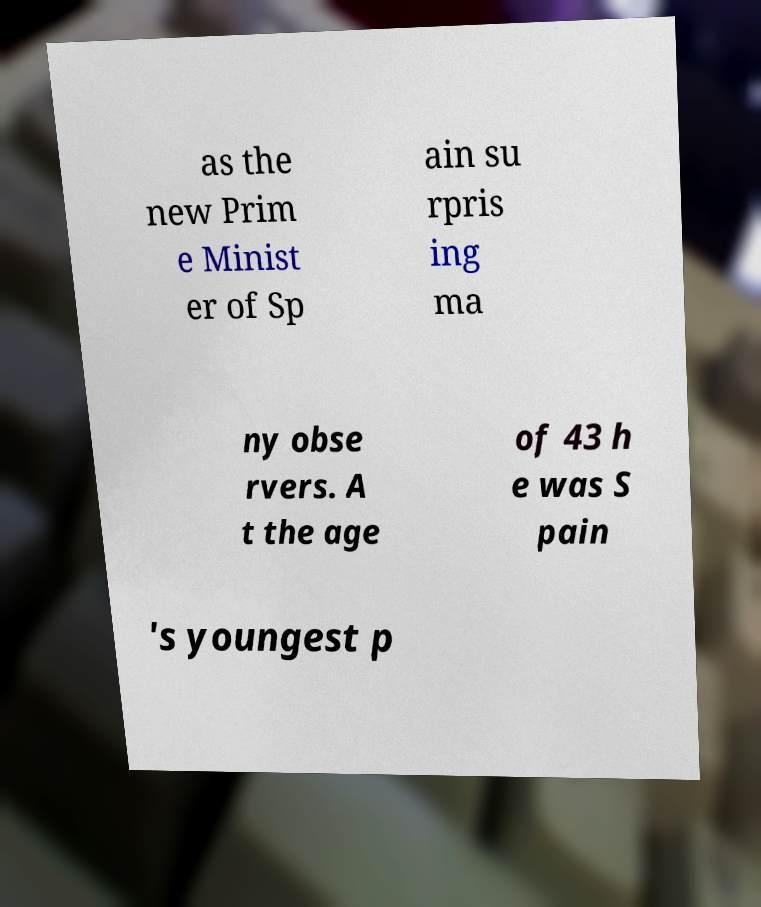Please read and relay the text visible in this image. What does it say? as the new Prim e Minist er of Sp ain su rpris ing ma ny obse rvers. A t the age of 43 h e was S pain 's youngest p 